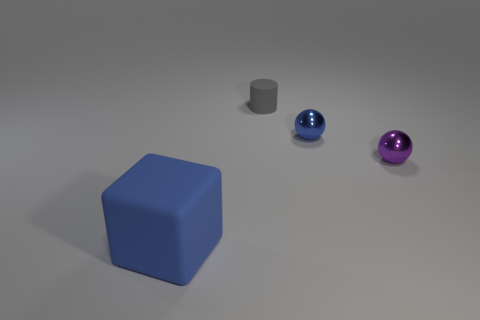Add 1 yellow cylinders. How many objects exist? 5 Subtract all blocks. How many objects are left? 3 Subtract all gray matte blocks. Subtract all tiny blue spheres. How many objects are left? 3 Add 1 cylinders. How many cylinders are left? 2 Add 4 tiny red shiny cylinders. How many tiny red shiny cylinders exist? 4 Subtract 1 gray cylinders. How many objects are left? 3 